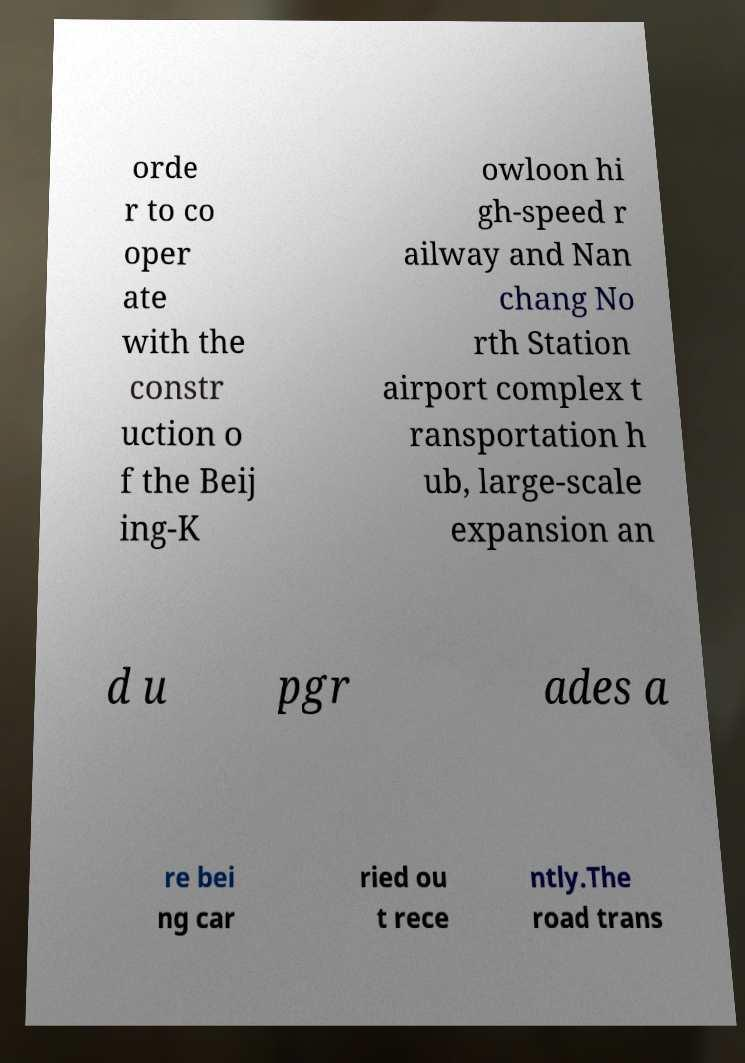Could you extract and type out the text from this image? orde r to co oper ate with the constr uction o f the Beij ing-K owloon hi gh-speed r ailway and Nan chang No rth Station airport complex t ransportation h ub, large-scale expansion an d u pgr ades a re bei ng car ried ou t rece ntly.The road trans 